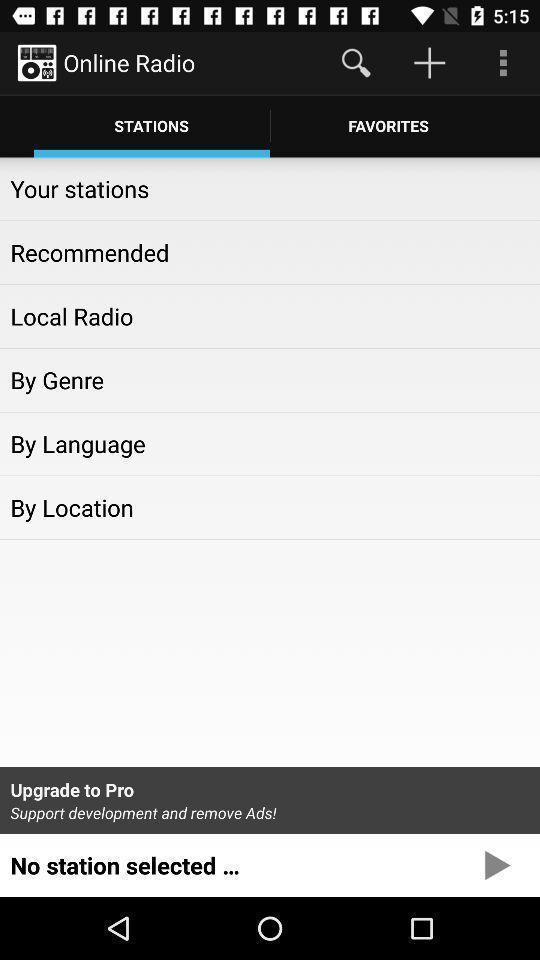Provide a detailed account of this screenshot. Stations screen with few options in entertainment app. 